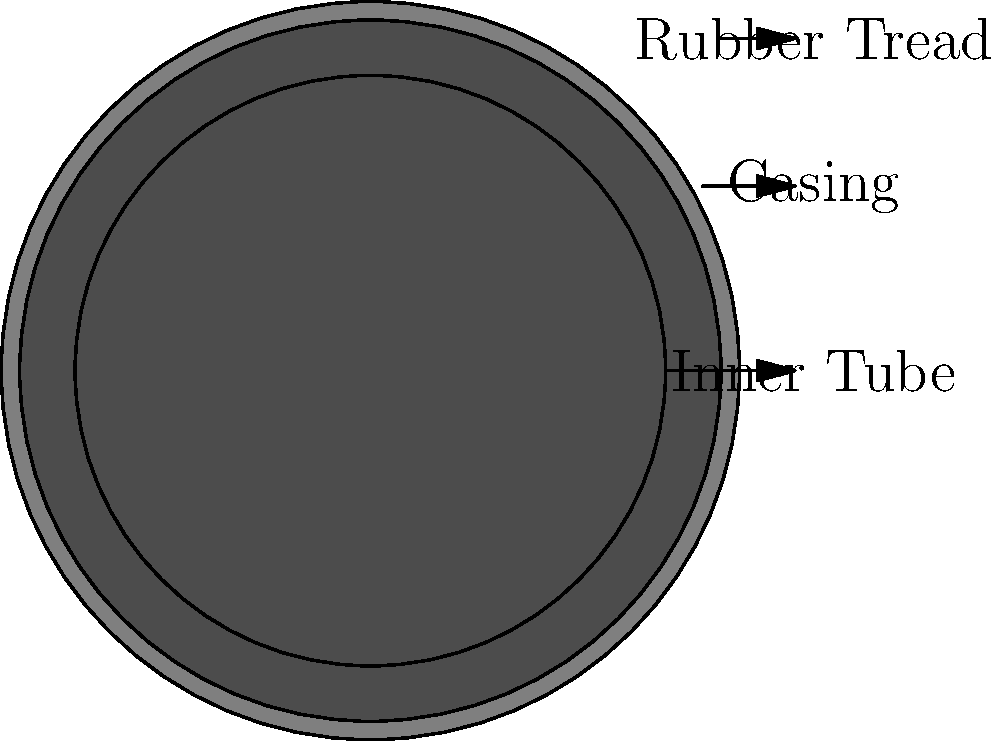In the cross-section of a bicycle tire shown above, what's the purpose of the innermost layer (labeled "Inner Tube")? Let's break down the structure of a bicycle tire:

1. The outermost layer is the rubber tread, which provides grip and protection.
2. The middle layer is the casing, which gives the tire its shape and strength.
3. The innermost layer is the inner tube.

The inner tube serves a crucial function:

1. It's made of flexible rubber or butyl.
2. It's designed to hold air pressure.
3. When inflated, it pushes against the outer layers of the tire.
4. This pressure gives the tire its shape and allows it to support the weight of the bicycle and rider.
5. The inner tube can be easily replaced if punctured, without needing to replace the entire tire.

In essence, the inner tube acts like a balloon inside the tire, providing the necessary air pressure to make the tire functional.
Answer: To hold air pressure and give the tire its shape 